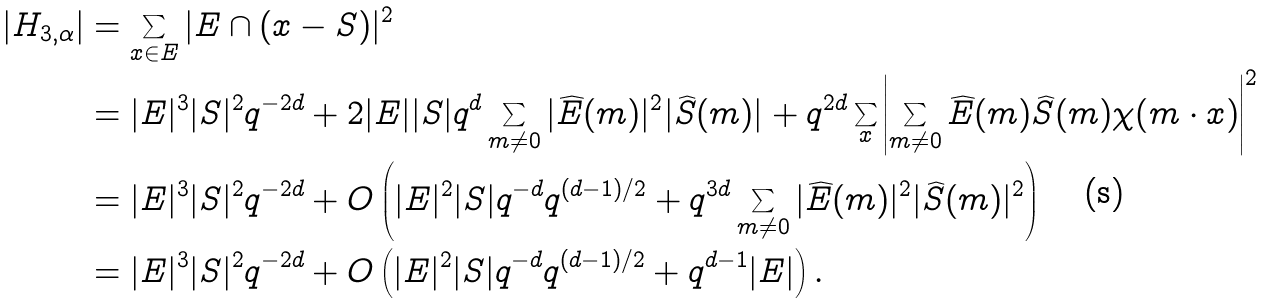<formula> <loc_0><loc_0><loc_500><loc_500>| H _ { 3 , \alpha } | & = \sum _ { x \in E } | E \cap ( x - S ) | ^ { 2 } \\ & = | E | ^ { 3 } | S | ^ { 2 } q ^ { - 2 d } + 2 | E | | S | q ^ { d } \sum _ { m \neq 0 } | \widehat { E } ( m ) | ^ { 2 } | \widehat { S } ( m ) | + q ^ { 2 d } \sum _ { x } \left | \sum _ { m \neq 0 } \widehat { E } ( m ) \widehat { S } ( m ) \chi ( m \cdot x ) \right | ^ { 2 } \\ & = | E | ^ { 3 } | S | ^ { 2 } q ^ { - 2 d } + O \left ( | E | ^ { 2 } | S | q ^ { - d } q ^ { ( d - 1 ) / 2 } + q ^ { 3 d } \sum _ { m \neq 0 } | \widehat { E } ( m ) | ^ { 2 } | \widehat { S } ( m ) | ^ { 2 } \right ) \\ & = | E | ^ { 3 } | S | ^ { 2 } q ^ { - 2 d } + O \left ( | E | ^ { 2 } | S | q ^ { - d } q ^ { ( d - 1 ) / 2 } + q ^ { d - 1 } | E | \right ) .</formula> 